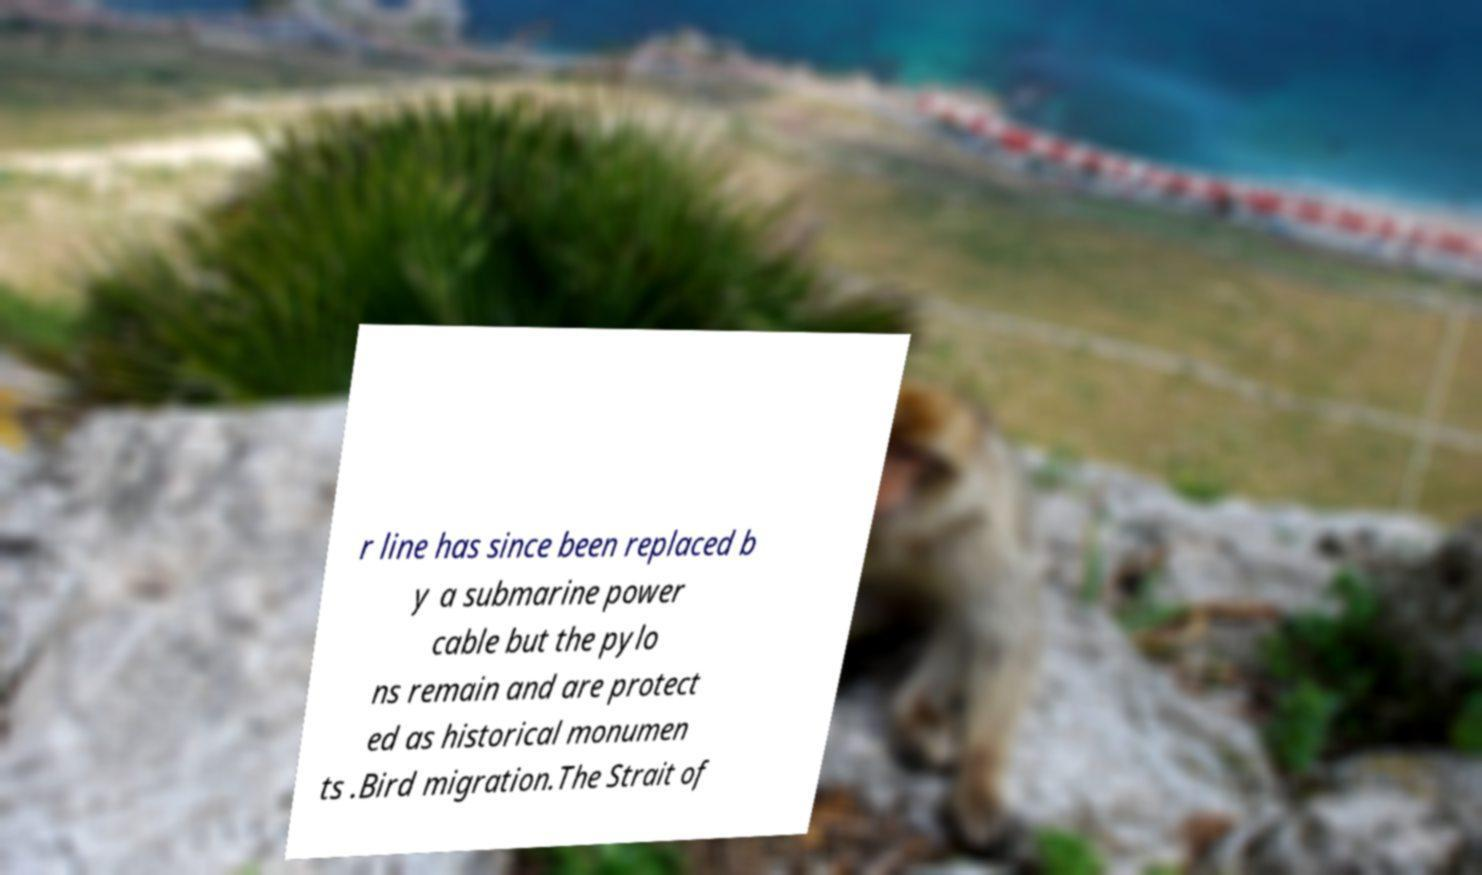Please read and relay the text visible in this image. What does it say? r line has since been replaced b y a submarine power cable but the pylo ns remain and are protect ed as historical monumen ts .Bird migration.The Strait of 